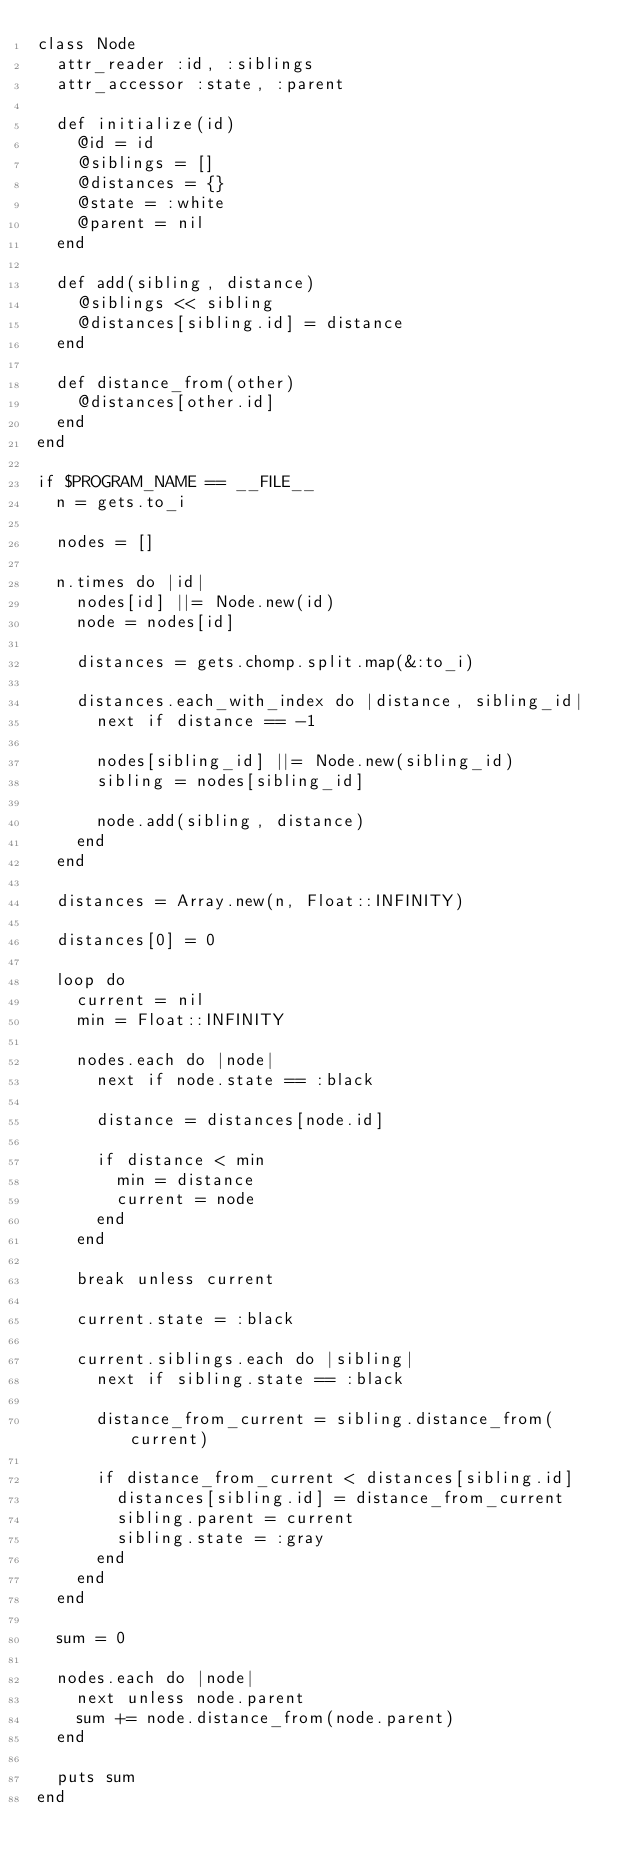<code> <loc_0><loc_0><loc_500><loc_500><_Ruby_>class Node
  attr_reader :id, :siblings
  attr_accessor :state, :parent

  def initialize(id)
    @id = id
    @siblings = []
    @distances = {}
    @state = :white
    @parent = nil
  end

  def add(sibling, distance)
    @siblings << sibling
    @distances[sibling.id] = distance
  end

  def distance_from(other)
    @distances[other.id]
  end
end

if $PROGRAM_NAME == __FILE__
  n = gets.to_i

  nodes = []

  n.times do |id|
    nodes[id] ||= Node.new(id)
    node = nodes[id]

    distances = gets.chomp.split.map(&:to_i)

    distances.each_with_index do |distance, sibling_id|
      next if distance == -1

      nodes[sibling_id] ||= Node.new(sibling_id)
      sibling = nodes[sibling_id]

      node.add(sibling, distance)
    end
  end

  distances = Array.new(n, Float::INFINITY)

  distances[0] = 0

  loop do
    current = nil
    min = Float::INFINITY

    nodes.each do |node|
      next if node.state == :black

      distance = distances[node.id]

      if distance < min
        min = distance
        current = node
      end
    end

    break unless current

    current.state = :black

    current.siblings.each do |sibling|
      next if sibling.state == :black

      distance_from_current = sibling.distance_from(current)

      if distance_from_current < distances[sibling.id]
        distances[sibling.id] = distance_from_current
        sibling.parent = current
        sibling.state = :gray
      end
    end
  end

  sum = 0

  nodes.each do |node|
    next unless node.parent
    sum += node.distance_from(node.parent)
  end

  puts sum
end</code> 